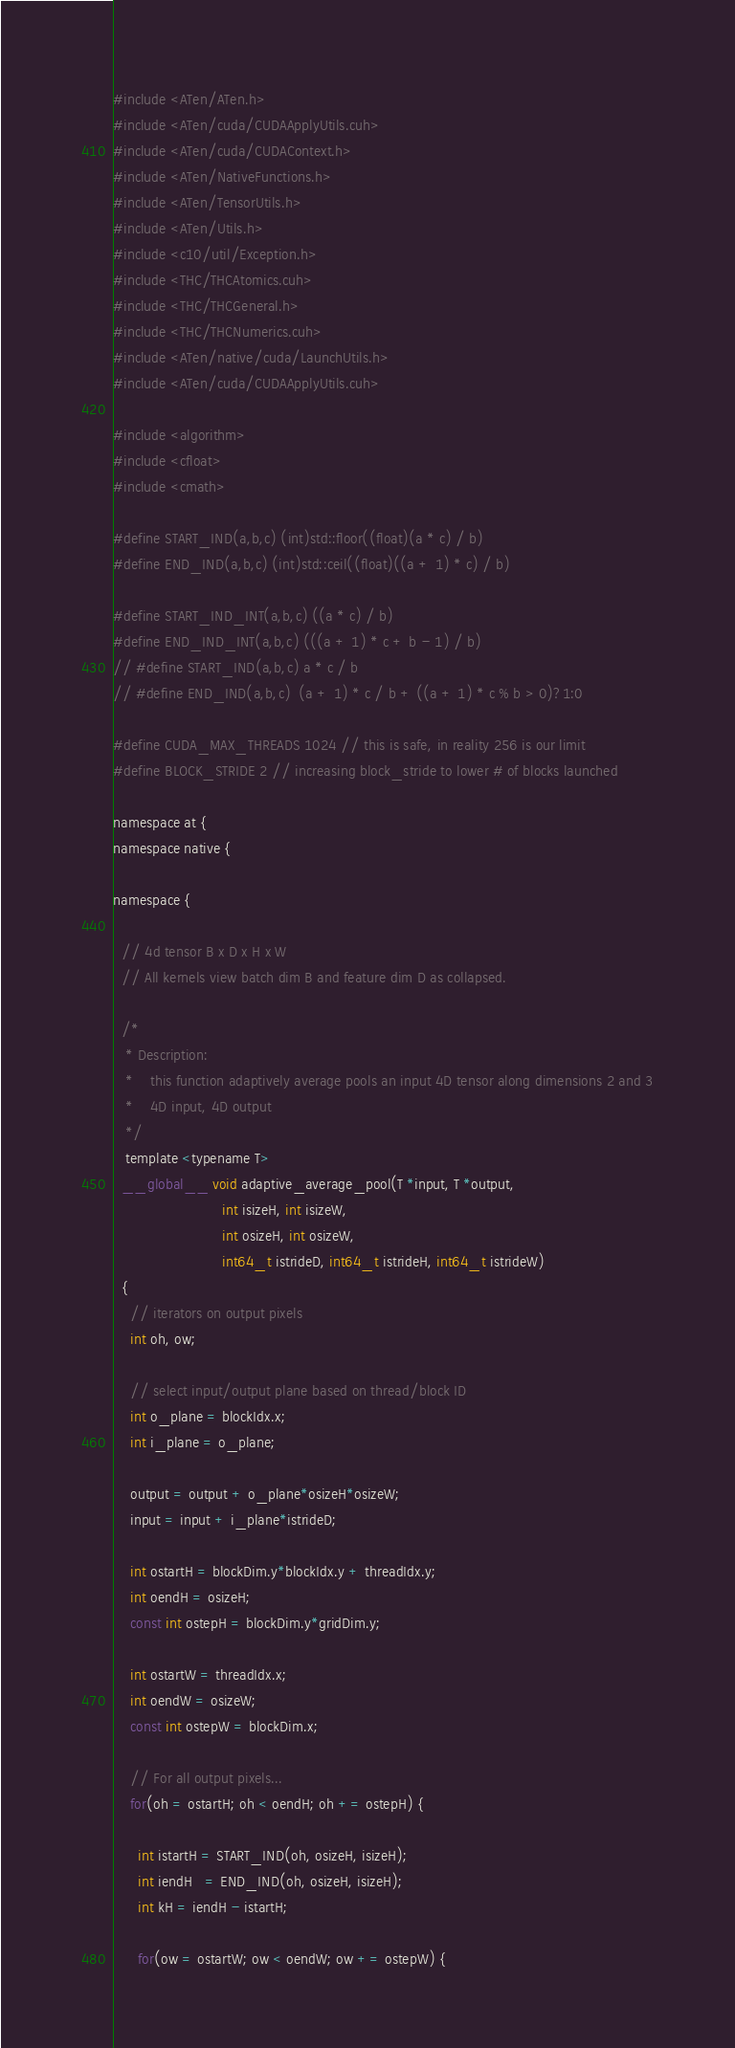Convert code to text. <code><loc_0><loc_0><loc_500><loc_500><_Cuda_>#include <ATen/ATen.h>
#include <ATen/cuda/CUDAApplyUtils.cuh>
#include <ATen/cuda/CUDAContext.h>
#include <ATen/NativeFunctions.h>
#include <ATen/TensorUtils.h>
#include <ATen/Utils.h>
#include <c10/util/Exception.h>
#include <THC/THCAtomics.cuh>
#include <THC/THCGeneral.h>
#include <THC/THCNumerics.cuh>
#include <ATen/native/cuda/LaunchUtils.h>
#include <ATen/cuda/CUDAApplyUtils.cuh>

#include <algorithm>
#include <cfloat>
#include <cmath>

#define START_IND(a,b,c) (int)std::floor((float)(a * c) / b)
#define END_IND(a,b,c) (int)std::ceil((float)((a + 1) * c) / b)

#define START_IND_INT(a,b,c) ((a * c) / b)
#define END_IND_INT(a,b,c) (((a + 1) * c + b - 1) / b)
// #define START_IND(a,b,c) a * c / b
// #define END_IND(a,b,c)  (a + 1) * c / b + ((a + 1) * c % b > 0)?1:0

#define CUDA_MAX_THREADS 1024 // this is safe, in reality 256 is our limit
#define BLOCK_STRIDE 2 // increasing block_stride to lower # of blocks launched

namespace at {
namespace native {

namespace {

  // 4d tensor B x D x H x W
  // All kernels view batch dim B and feature dim D as collapsed.

  /*
   * Description:
   *    this function adaptively average pools an input 4D tensor along dimensions 2 and 3
   *    4D input, 4D output
   */
   template <typename T>
  __global__ void adaptive_average_pool(T *input, T *output,
                          int isizeH, int isizeW,
                          int osizeH, int osizeW,
                          int64_t istrideD, int64_t istrideH, int64_t istrideW)
  {
    // iterators on output pixels
    int oh, ow;

    // select input/output plane based on thread/block ID
    int o_plane = blockIdx.x;
    int i_plane = o_plane;

    output = output + o_plane*osizeH*osizeW;
    input = input + i_plane*istrideD;

    int ostartH = blockDim.y*blockIdx.y + threadIdx.y;
    int oendH = osizeH;
    const int ostepH = blockDim.y*gridDim.y;

    int ostartW = threadIdx.x;
    int oendW = osizeW;
    const int ostepW = blockDim.x;

    // For all output pixels...
    for(oh = ostartH; oh < oendH; oh += ostepH) {

      int istartH = START_IND(oh, osizeH, isizeH);
      int iendH   = END_IND(oh, osizeH, isizeH);
      int kH = iendH - istartH;

      for(ow = ostartW; ow < oendW; ow += ostepW) {
</code> 